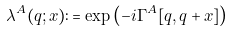Convert formula to latex. <formula><loc_0><loc_0><loc_500><loc_500>\lambda ^ { A } ( q ; x ) \colon = \exp \left ( - i \Gamma ^ { A } [ q , q + x ] \right )</formula> 